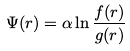<formula> <loc_0><loc_0><loc_500><loc_500>\Psi ( { r } ) = \alpha \ln \frac { f ( r ) } { g ( r ) }</formula> 